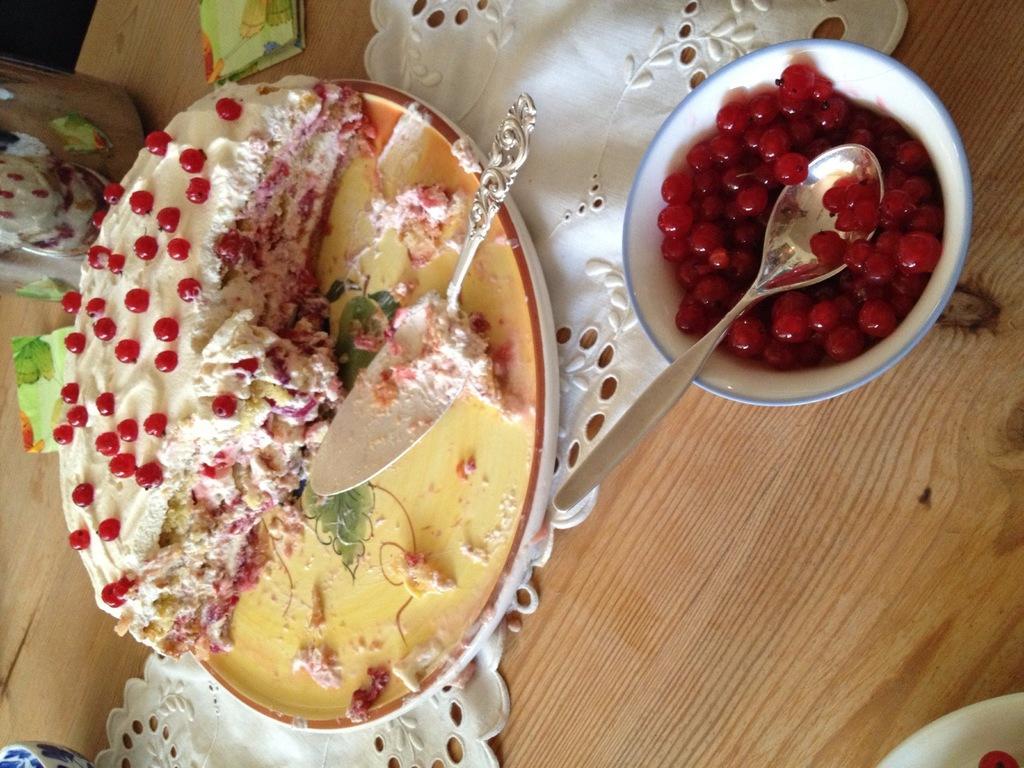Can you describe this image briefly? In this image there is a table, there is a cloth on the table, there is a bowl on the table, there is food in the bowl, there is a cake, there is a spoon, there are objects on the table. 